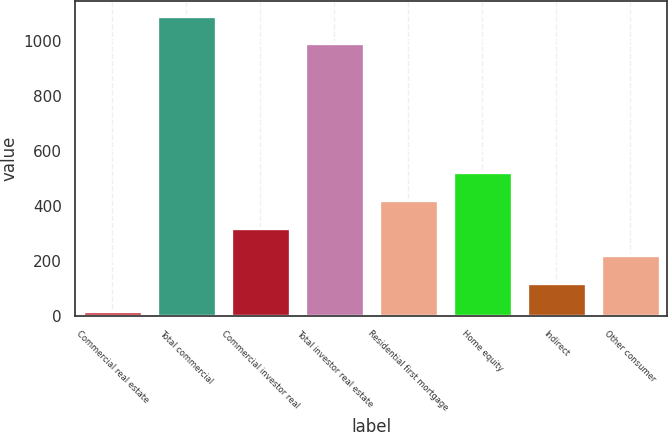<chart> <loc_0><loc_0><loc_500><loc_500><bar_chart><fcel>Commercial real estate<fcel>Total commercial<fcel>Commercial investor real<fcel>Total investor real estate<fcel>Residential first mortgage<fcel>Home equity<fcel>Indirect<fcel>Other consumer<nl><fcel>17<fcel>1092.3<fcel>320.9<fcel>991<fcel>422.2<fcel>523.5<fcel>118.3<fcel>219.6<nl></chart> 